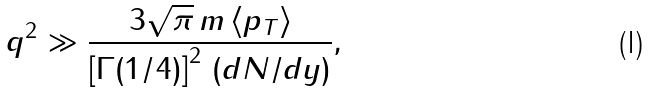Convert formula to latex. <formula><loc_0><loc_0><loc_500><loc_500>q ^ { 2 } \gg \frac { 3 \sqrt { \pi } \, m \, \langle p _ { T } \rangle } { \left [ \Gamma ( 1 / 4 ) \right ] ^ { 2 } \, ( d N / d y ) } ,</formula> 